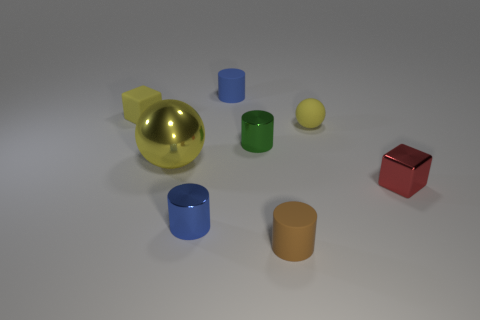Add 1 red objects. How many objects exist? 9 Subtract all cubes. How many objects are left? 6 Add 3 blue cylinders. How many blue cylinders are left? 5 Add 2 large yellow objects. How many large yellow objects exist? 3 Subtract 1 red blocks. How many objects are left? 7 Subtract all large gray shiny cylinders. Subtract all small yellow rubber blocks. How many objects are left? 7 